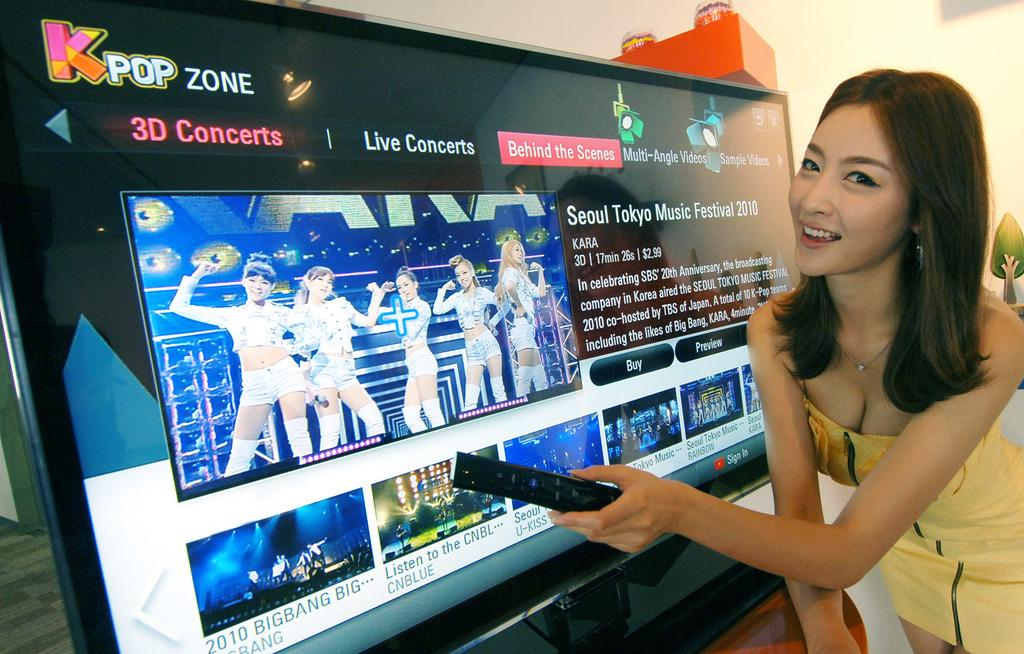<image>
Present a compact description of the photo's key features. A girl is holding a remote looking at Kpop Zone 